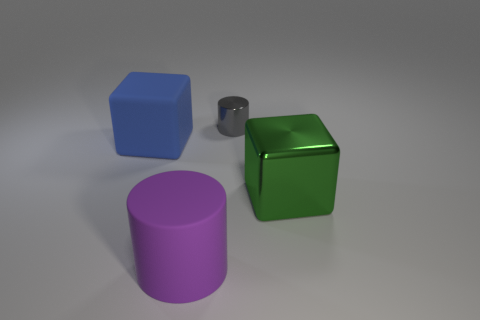Does the large thing on the right side of the large purple matte cylinder have the same shape as the rubber object behind the large green thing?
Your response must be concise. Yes. What size is the other thing that is the same shape as the blue matte thing?
Ensure brevity in your answer.  Large. There is a object that is both left of the big green cube and in front of the matte cube; what shape is it?
Give a very brief answer. Cylinder. There is a purple cylinder; does it have the same size as the block behind the green cube?
Offer a very short reply. Yes. What color is the other object that is the same shape as the big blue matte object?
Ensure brevity in your answer.  Green. Is the size of the cylinder in front of the rubber cube the same as the cylinder that is behind the matte cube?
Provide a short and direct response. No. Does the tiny gray object have the same shape as the large purple matte object?
Your answer should be very brief. Yes. How many objects are metallic things that are behind the large green cube or big green matte balls?
Keep it short and to the point. 1. Is there another tiny gray object of the same shape as the small metallic thing?
Offer a terse response. No. Are there an equal number of blue objects that are to the left of the big blue rubber thing and small cyan matte objects?
Ensure brevity in your answer.  Yes. 